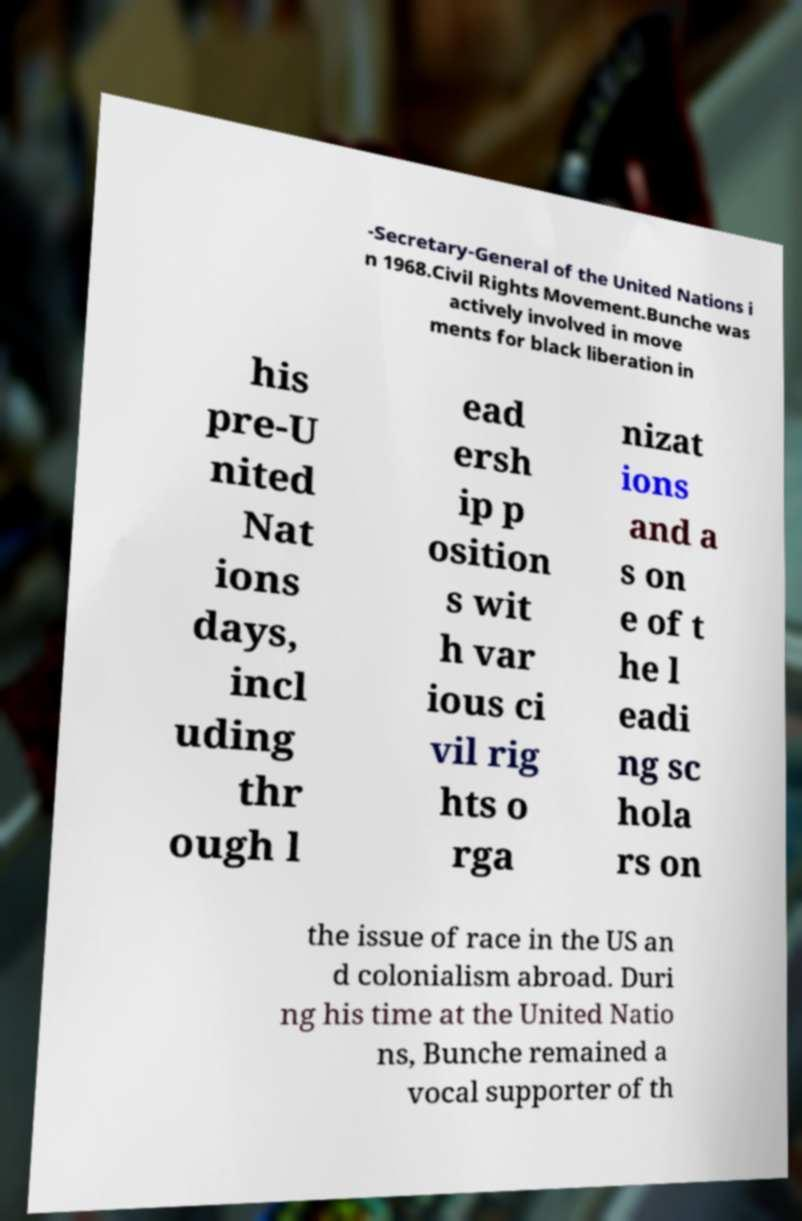For documentation purposes, I need the text within this image transcribed. Could you provide that? -Secretary-General of the United Nations i n 1968.Civil Rights Movement.Bunche was actively involved in move ments for black liberation in his pre-U nited Nat ions days, incl uding thr ough l ead ersh ip p osition s wit h var ious ci vil rig hts o rga nizat ions and a s on e of t he l eadi ng sc hola rs on the issue of race in the US an d colonialism abroad. Duri ng his time at the United Natio ns, Bunche remained a vocal supporter of th 